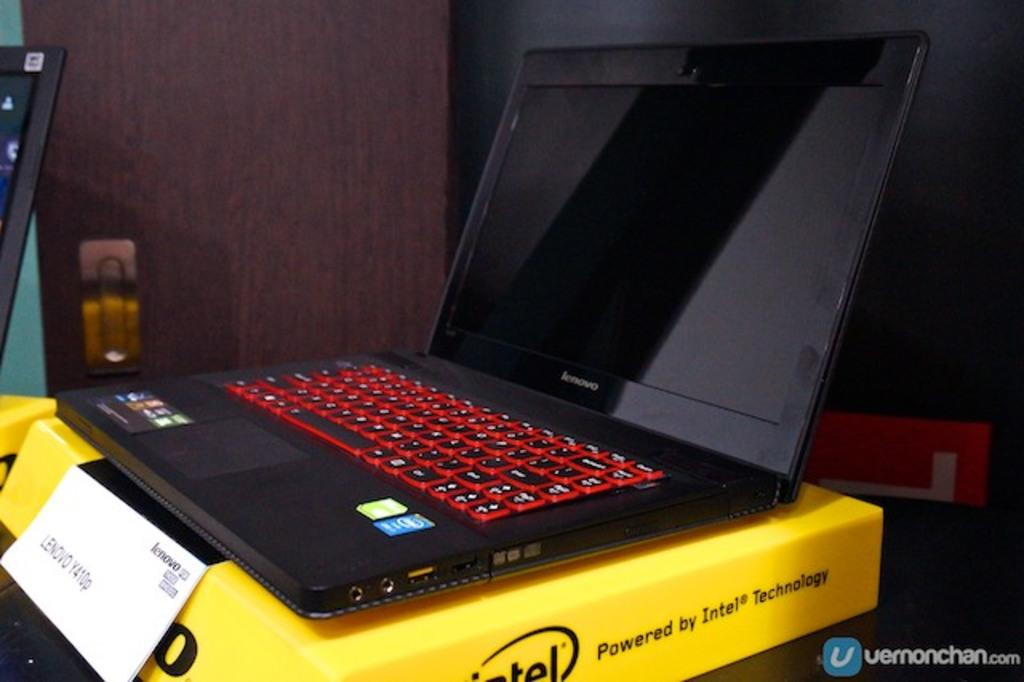<image>
Relay a brief, clear account of the picture shown. A black lenovo laptop placed on a yellow box. 